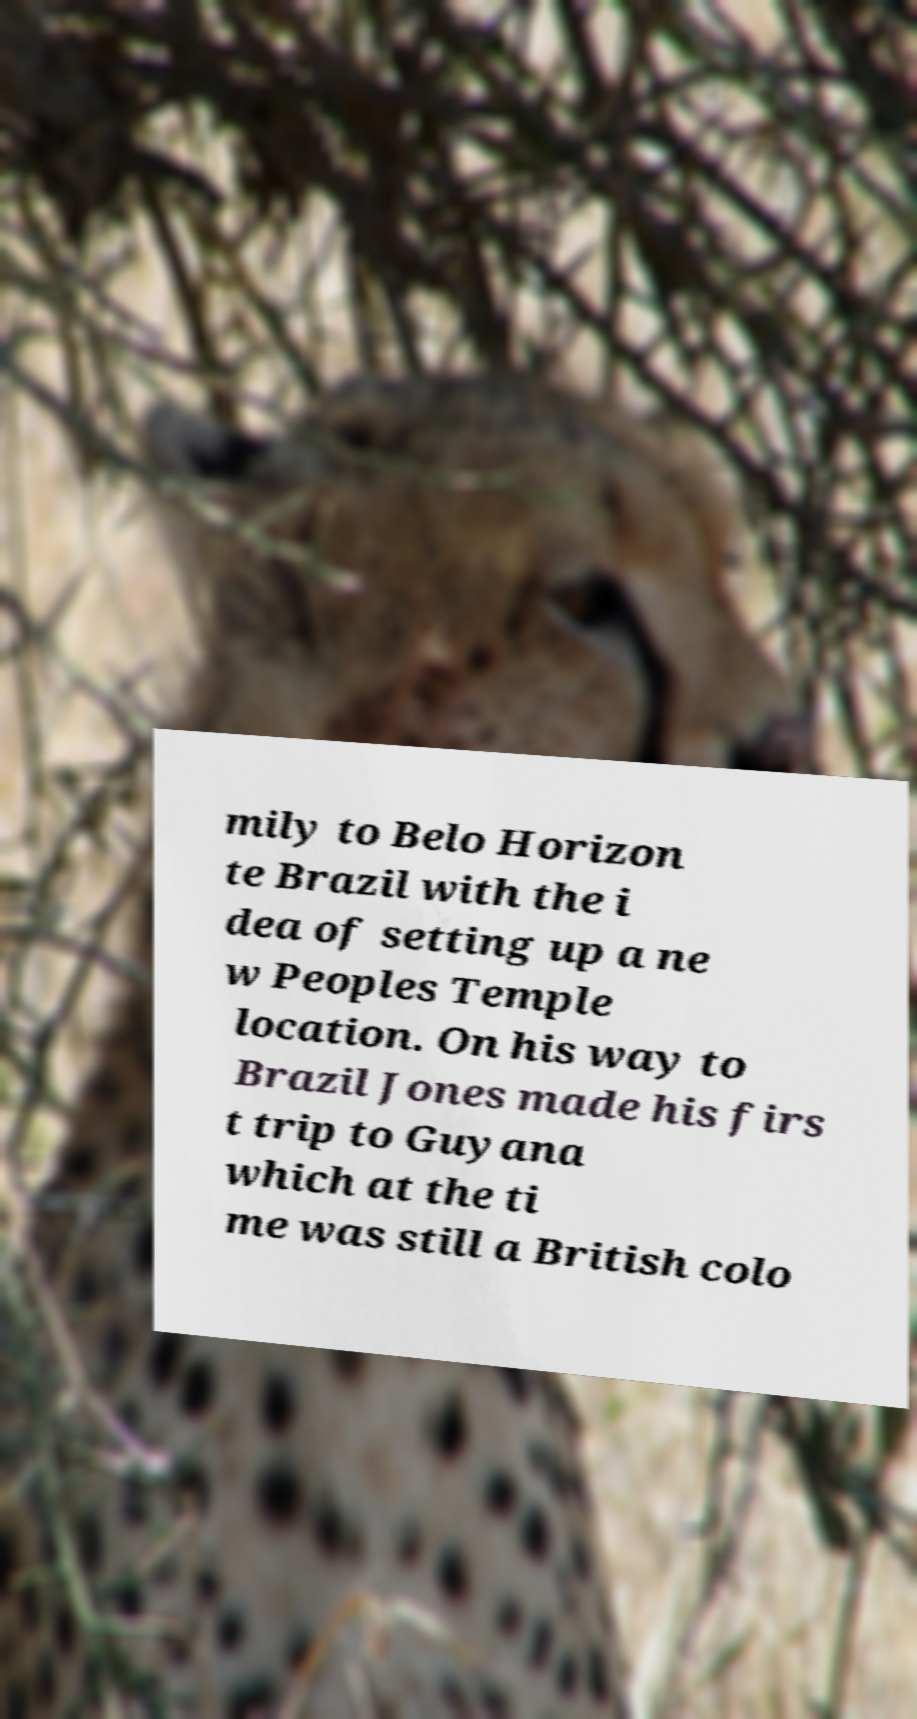Could you assist in decoding the text presented in this image and type it out clearly? mily to Belo Horizon te Brazil with the i dea of setting up a ne w Peoples Temple location. On his way to Brazil Jones made his firs t trip to Guyana which at the ti me was still a British colo 